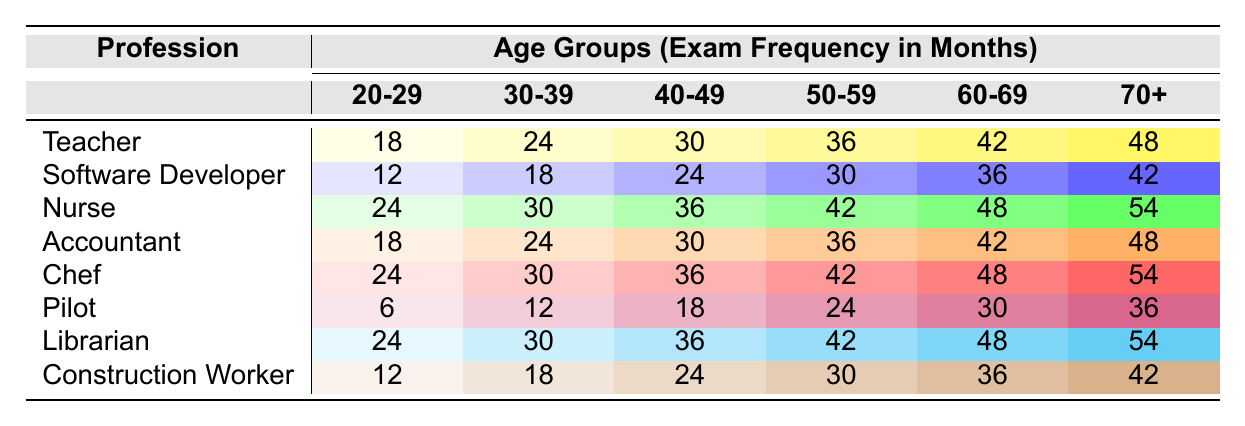What is the exam frequency for teachers aged 40-49? The exam frequency for teachers in the 40-49 age group is found in the table under the "Teacher" row and "40-49" column. The corresponding value is 30.
Answer: 30 Which profession has the least frequent eye exams among those aged 20-29? Looking at the "20-29" column, the least number of months for eye exams is with the Software Developer profession, which is 12 months.
Answer: Software Developer What is the average exam frequency for nurses across all age groups? To find the average frequency for nurses, sum the values in the nurse's row: 24 + 30 + 36 + 42 + 48 + 54 = 234. There are 6 age groups, so the average is 234/6 = 39.
Answer: 39 Does the pilot have a higher or lower exam frequency than the chef in the 50-59 age group? For the 50-59 age group, the pilot has an exam frequency of 24 months and the chef has 42 months. Thus, the pilot has a lower exam frequency than the chef.
Answer: Lower Which two professions have the highest exam frequency for the age group 60-69? In the "60-69" column, both nurses and chefs have an exam frequency of 48 months (the highest). Therefore, the two professions are Nurse and Chef.
Answer: Nurse and Chef What is the difference in exam frequency for construction workers between age groups 30-39 and 50-59? The exam frequency for construction workers is 18 months for age group 30-39 and 30 months for 50-59. The difference is 30 - 18 = 12 months.
Answer: 12 Is it true that teachers have a higher exam frequency than accountants for the age group 70+? For the age group 70+, teachers have an exam frequency of 48 months, while accountants also have 48 months. Therefore, it is false that teachers have a higher frequency.
Answer: False What is the total exam frequency for all age groups of librarians? To get the total for librarians, add 24 + 30 + 36 + 42 + 48 + 54 = 234 months.
Answer: 234 In which age group do pilots have the lowest exam frequency? The lowest exam frequency for pilots is found under the "70+" row and is equal to 36 months, indicating that this is their lowest frequency.
Answer: 70+ Which profession shows a consistent increase in exam frequency from ages 20-29 to 70+? Examining the table, we see that the Nurse profession consistently increases in exam frequency: 24, 30, 36, 42, 48, and 54 months respectively.
Answer: Nurse 